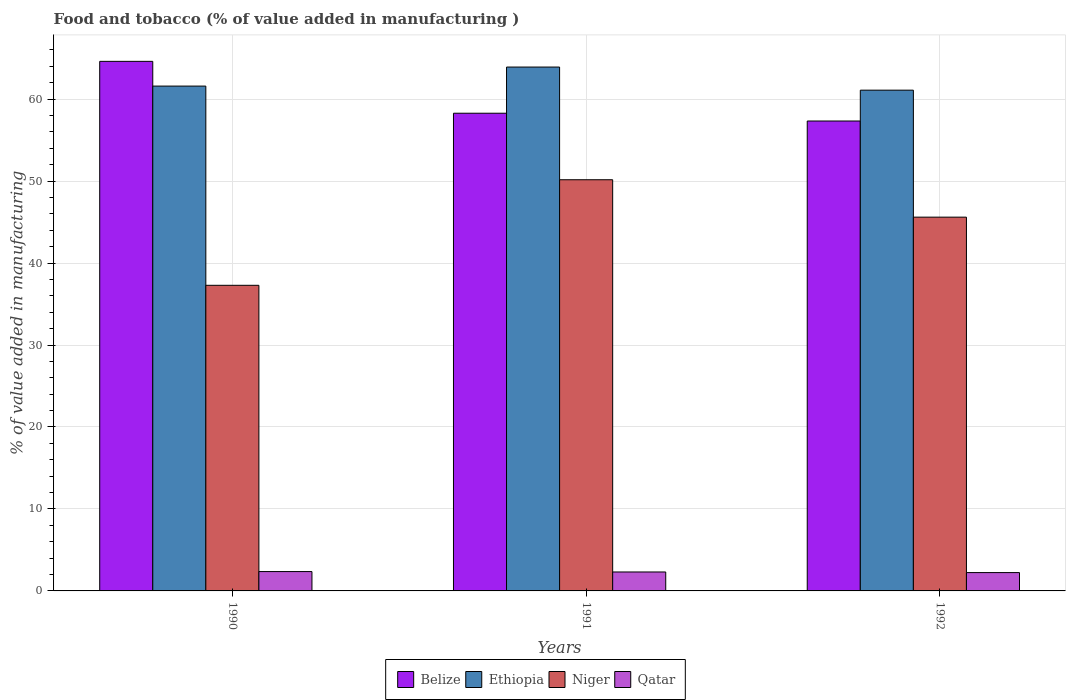How many groups of bars are there?
Offer a terse response. 3. Are the number of bars per tick equal to the number of legend labels?
Provide a short and direct response. Yes. How many bars are there on the 3rd tick from the left?
Ensure brevity in your answer.  4. In how many cases, is the number of bars for a given year not equal to the number of legend labels?
Give a very brief answer. 0. What is the value added in manufacturing food and tobacco in Belize in 1991?
Ensure brevity in your answer.  58.28. Across all years, what is the maximum value added in manufacturing food and tobacco in Belize?
Provide a succinct answer. 64.61. Across all years, what is the minimum value added in manufacturing food and tobacco in Ethiopia?
Make the answer very short. 61.09. In which year was the value added in manufacturing food and tobacco in Ethiopia maximum?
Provide a short and direct response. 1991. What is the total value added in manufacturing food and tobacco in Belize in the graph?
Your response must be concise. 180.21. What is the difference between the value added in manufacturing food and tobacco in Qatar in 1990 and that in 1991?
Offer a very short reply. 0.05. What is the difference between the value added in manufacturing food and tobacco in Niger in 1992 and the value added in manufacturing food and tobacco in Qatar in 1990?
Offer a terse response. 43.24. What is the average value added in manufacturing food and tobacco in Niger per year?
Keep it short and to the point. 44.35. In the year 1990, what is the difference between the value added in manufacturing food and tobacco in Ethiopia and value added in manufacturing food and tobacco in Qatar?
Your response must be concise. 59.23. What is the ratio of the value added in manufacturing food and tobacco in Niger in 1991 to that in 1992?
Your answer should be very brief. 1.1. Is the value added in manufacturing food and tobacco in Belize in 1991 less than that in 1992?
Your answer should be very brief. No. What is the difference between the highest and the second highest value added in manufacturing food and tobacco in Belize?
Provide a succinct answer. 6.33. What is the difference between the highest and the lowest value added in manufacturing food and tobacco in Belize?
Keep it short and to the point. 7.28. In how many years, is the value added in manufacturing food and tobacco in Qatar greater than the average value added in manufacturing food and tobacco in Qatar taken over all years?
Your answer should be very brief. 2. Is the sum of the value added in manufacturing food and tobacco in Belize in 1991 and 1992 greater than the maximum value added in manufacturing food and tobacco in Ethiopia across all years?
Your response must be concise. Yes. Is it the case that in every year, the sum of the value added in manufacturing food and tobacco in Belize and value added in manufacturing food and tobacco in Qatar is greater than the sum of value added in manufacturing food and tobacco in Niger and value added in manufacturing food and tobacco in Ethiopia?
Your response must be concise. Yes. What does the 1st bar from the left in 1991 represents?
Your answer should be compact. Belize. What does the 4th bar from the right in 1991 represents?
Provide a succinct answer. Belize. Is it the case that in every year, the sum of the value added in manufacturing food and tobacco in Belize and value added in manufacturing food and tobacco in Qatar is greater than the value added in manufacturing food and tobacco in Niger?
Your response must be concise. Yes. Are all the bars in the graph horizontal?
Ensure brevity in your answer.  No. Does the graph contain any zero values?
Your answer should be compact. No. How are the legend labels stacked?
Make the answer very short. Horizontal. What is the title of the graph?
Offer a very short reply. Food and tobacco (% of value added in manufacturing ). What is the label or title of the Y-axis?
Offer a very short reply. % of value added in manufacturing. What is the % of value added in manufacturing of Belize in 1990?
Your response must be concise. 64.61. What is the % of value added in manufacturing in Ethiopia in 1990?
Your answer should be compact. 61.59. What is the % of value added in manufacturing in Niger in 1990?
Make the answer very short. 37.28. What is the % of value added in manufacturing in Qatar in 1990?
Provide a short and direct response. 2.36. What is the % of value added in manufacturing in Belize in 1991?
Your response must be concise. 58.28. What is the % of value added in manufacturing in Ethiopia in 1991?
Provide a succinct answer. 63.91. What is the % of value added in manufacturing of Niger in 1991?
Your response must be concise. 50.16. What is the % of value added in manufacturing of Qatar in 1991?
Offer a very short reply. 2.31. What is the % of value added in manufacturing of Belize in 1992?
Your response must be concise. 57.33. What is the % of value added in manufacturing in Ethiopia in 1992?
Provide a short and direct response. 61.09. What is the % of value added in manufacturing in Niger in 1992?
Your answer should be very brief. 45.6. What is the % of value added in manufacturing in Qatar in 1992?
Make the answer very short. 2.24. Across all years, what is the maximum % of value added in manufacturing of Belize?
Provide a succinct answer. 64.61. Across all years, what is the maximum % of value added in manufacturing in Ethiopia?
Your answer should be compact. 63.91. Across all years, what is the maximum % of value added in manufacturing of Niger?
Your answer should be compact. 50.16. Across all years, what is the maximum % of value added in manufacturing of Qatar?
Your response must be concise. 2.36. Across all years, what is the minimum % of value added in manufacturing in Belize?
Make the answer very short. 57.33. Across all years, what is the minimum % of value added in manufacturing in Ethiopia?
Offer a terse response. 61.09. Across all years, what is the minimum % of value added in manufacturing of Niger?
Provide a succinct answer. 37.28. Across all years, what is the minimum % of value added in manufacturing in Qatar?
Offer a very short reply. 2.24. What is the total % of value added in manufacturing of Belize in the graph?
Provide a succinct answer. 180.21. What is the total % of value added in manufacturing in Ethiopia in the graph?
Give a very brief answer. 186.59. What is the total % of value added in manufacturing in Niger in the graph?
Give a very brief answer. 133.05. What is the total % of value added in manufacturing in Qatar in the graph?
Provide a short and direct response. 6.91. What is the difference between the % of value added in manufacturing in Belize in 1990 and that in 1991?
Provide a succinct answer. 6.33. What is the difference between the % of value added in manufacturing of Ethiopia in 1990 and that in 1991?
Your answer should be compact. -2.32. What is the difference between the % of value added in manufacturing in Niger in 1990 and that in 1991?
Keep it short and to the point. -12.88. What is the difference between the % of value added in manufacturing of Qatar in 1990 and that in 1991?
Provide a succinct answer. 0.05. What is the difference between the % of value added in manufacturing of Belize in 1990 and that in 1992?
Your answer should be very brief. 7.28. What is the difference between the % of value added in manufacturing in Ethiopia in 1990 and that in 1992?
Ensure brevity in your answer.  0.5. What is the difference between the % of value added in manufacturing in Niger in 1990 and that in 1992?
Make the answer very short. -8.32. What is the difference between the % of value added in manufacturing in Qatar in 1990 and that in 1992?
Provide a succinct answer. 0.12. What is the difference between the % of value added in manufacturing of Belize in 1991 and that in 1992?
Your answer should be very brief. 0.95. What is the difference between the % of value added in manufacturing of Ethiopia in 1991 and that in 1992?
Make the answer very short. 2.82. What is the difference between the % of value added in manufacturing in Niger in 1991 and that in 1992?
Keep it short and to the point. 4.56. What is the difference between the % of value added in manufacturing in Qatar in 1991 and that in 1992?
Offer a very short reply. 0.07. What is the difference between the % of value added in manufacturing of Belize in 1990 and the % of value added in manufacturing of Ethiopia in 1991?
Ensure brevity in your answer.  0.7. What is the difference between the % of value added in manufacturing of Belize in 1990 and the % of value added in manufacturing of Niger in 1991?
Provide a succinct answer. 14.44. What is the difference between the % of value added in manufacturing of Belize in 1990 and the % of value added in manufacturing of Qatar in 1991?
Make the answer very short. 62.29. What is the difference between the % of value added in manufacturing in Ethiopia in 1990 and the % of value added in manufacturing in Niger in 1991?
Ensure brevity in your answer.  11.43. What is the difference between the % of value added in manufacturing in Ethiopia in 1990 and the % of value added in manufacturing in Qatar in 1991?
Your response must be concise. 59.28. What is the difference between the % of value added in manufacturing in Niger in 1990 and the % of value added in manufacturing in Qatar in 1991?
Give a very brief answer. 34.97. What is the difference between the % of value added in manufacturing in Belize in 1990 and the % of value added in manufacturing in Ethiopia in 1992?
Ensure brevity in your answer.  3.51. What is the difference between the % of value added in manufacturing of Belize in 1990 and the % of value added in manufacturing of Niger in 1992?
Provide a succinct answer. 19.01. What is the difference between the % of value added in manufacturing in Belize in 1990 and the % of value added in manufacturing in Qatar in 1992?
Your response must be concise. 62.37. What is the difference between the % of value added in manufacturing in Ethiopia in 1990 and the % of value added in manufacturing in Niger in 1992?
Your response must be concise. 15.99. What is the difference between the % of value added in manufacturing in Ethiopia in 1990 and the % of value added in manufacturing in Qatar in 1992?
Make the answer very short. 59.35. What is the difference between the % of value added in manufacturing of Niger in 1990 and the % of value added in manufacturing of Qatar in 1992?
Your answer should be compact. 35.05. What is the difference between the % of value added in manufacturing of Belize in 1991 and the % of value added in manufacturing of Ethiopia in 1992?
Your answer should be very brief. -2.81. What is the difference between the % of value added in manufacturing of Belize in 1991 and the % of value added in manufacturing of Niger in 1992?
Offer a terse response. 12.68. What is the difference between the % of value added in manufacturing in Belize in 1991 and the % of value added in manufacturing in Qatar in 1992?
Provide a short and direct response. 56.04. What is the difference between the % of value added in manufacturing in Ethiopia in 1991 and the % of value added in manufacturing in Niger in 1992?
Keep it short and to the point. 18.31. What is the difference between the % of value added in manufacturing in Ethiopia in 1991 and the % of value added in manufacturing in Qatar in 1992?
Your response must be concise. 61.67. What is the difference between the % of value added in manufacturing of Niger in 1991 and the % of value added in manufacturing of Qatar in 1992?
Provide a succinct answer. 47.93. What is the average % of value added in manufacturing of Belize per year?
Your answer should be compact. 60.07. What is the average % of value added in manufacturing in Ethiopia per year?
Offer a terse response. 62.2. What is the average % of value added in manufacturing of Niger per year?
Make the answer very short. 44.35. What is the average % of value added in manufacturing of Qatar per year?
Make the answer very short. 2.3. In the year 1990, what is the difference between the % of value added in manufacturing in Belize and % of value added in manufacturing in Ethiopia?
Offer a terse response. 3.02. In the year 1990, what is the difference between the % of value added in manufacturing of Belize and % of value added in manufacturing of Niger?
Give a very brief answer. 27.32. In the year 1990, what is the difference between the % of value added in manufacturing in Belize and % of value added in manufacturing in Qatar?
Your answer should be compact. 62.25. In the year 1990, what is the difference between the % of value added in manufacturing of Ethiopia and % of value added in manufacturing of Niger?
Your answer should be compact. 24.3. In the year 1990, what is the difference between the % of value added in manufacturing of Ethiopia and % of value added in manufacturing of Qatar?
Keep it short and to the point. 59.23. In the year 1990, what is the difference between the % of value added in manufacturing in Niger and % of value added in manufacturing in Qatar?
Your answer should be very brief. 34.92. In the year 1991, what is the difference between the % of value added in manufacturing in Belize and % of value added in manufacturing in Ethiopia?
Your response must be concise. -5.63. In the year 1991, what is the difference between the % of value added in manufacturing of Belize and % of value added in manufacturing of Niger?
Keep it short and to the point. 8.11. In the year 1991, what is the difference between the % of value added in manufacturing in Belize and % of value added in manufacturing in Qatar?
Your response must be concise. 55.97. In the year 1991, what is the difference between the % of value added in manufacturing of Ethiopia and % of value added in manufacturing of Niger?
Your response must be concise. 13.75. In the year 1991, what is the difference between the % of value added in manufacturing in Ethiopia and % of value added in manufacturing in Qatar?
Ensure brevity in your answer.  61.6. In the year 1991, what is the difference between the % of value added in manufacturing in Niger and % of value added in manufacturing in Qatar?
Your answer should be compact. 47.85. In the year 1992, what is the difference between the % of value added in manufacturing in Belize and % of value added in manufacturing in Ethiopia?
Offer a very short reply. -3.76. In the year 1992, what is the difference between the % of value added in manufacturing in Belize and % of value added in manufacturing in Niger?
Offer a terse response. 11.73. In the year 1992, what is the difference between the % of value added in manufacturing of Belize and % of value added in manufacturing of Qatar?
Ensure brevity in your answer.  55.09. In the year 1992, what is the difference between the % of value added in manufacturing of Ethiopia and % of value added in manufacturing of Niger?
Make the answer very short. 15.49. In the year 1992, what is the difference between the % of value added in manufacturing of Ethiopia and % of value added in manufacturing of Qatar?
Provide a succinct answer. 58.85. In the year 1992, what is the difference between the % of value added in manufacturing in Niger and % of value added in manufacturing in Qatar?
Provide a succinct answer. 43.36. What is the ratio of the % of value added in manufacturing of Belize in 1990 to that in 1991?
Your answer should be very brief. 1.11. What is the ratio of the % of value added in manufacturing in Ethiopia in 1990 to that in 1991?
Your response must be concise. 0.96. What is the ratio of the % of value added in manufacturing in Niger in 1990 to that in 1991?
Keep it short and to the point. 0.74. What is the ratio of the % of value added in manufacturing in Qatar in 1990 to that in 1991?
Offer a terse response. 1.02. What is the ratio of the % of value added in manufacturing in Belize in 1990 to that in 1992?
Provide a short and direct response. 1.13. What is the ratio of the % of value added in manufacturing of Niger in 1990 to that in 1992?
Provide a succinct answer. 0.82. What is the ratio of the % of value added in manufacturing of Qatar in 1990 to that in 1992?
Your response must be concise. 1.05. What is the ratio of the % of value added in manufacturing of Belize in 1991 to that in 1992?
Your answer should be compact. 1.02. What is the ratio of the % of value added in manufacturing in Ethiopia in 1991 to that in 1992?
Give a very brief answer. 1.05. What is the ratio of the % of value added in manufacturing of Niger in 1991 to that in 1992?
Make the answer very short. 1.1. What is the ratio of the % of value added in manufacturing in Qatar in 1991 to that in 1992?
Your answer should be compact. 1.03. What is the difference between the highest and the second highest % of value added in manufacturing of Belize?
Ensure brevity in your answer.  6.33. What is the difference between the highest and the second highest % of value added in manufacturing in Ethiopia?
Ensure brevity in your answer.  2.32. What is the difference between the highest and the second highest % of value added in manufacturing of Niger?
Keep it short and to the point. 4.56. What is the difference between the highest and the second highest % of value added in manufacturing of Qatar?
Your response must be concise. 0.05. What is the difference between the highest and the lowest % of value added in manufacturing of Belize?
Provide a short and direct response. 7.28. What is the difference between the highest and the lowest % of value added in manufacturing of Ethiopia?
Provide a short and direct response. 2.82. What is the difference between the highest and the lowest % of value added in manufacturing in Niger?
Provide a succinct answer. 12.88. What is the difference between the highest and the lowest % of value added in manufacturing in Qatar?
Offer a very short reply. 0.12. 